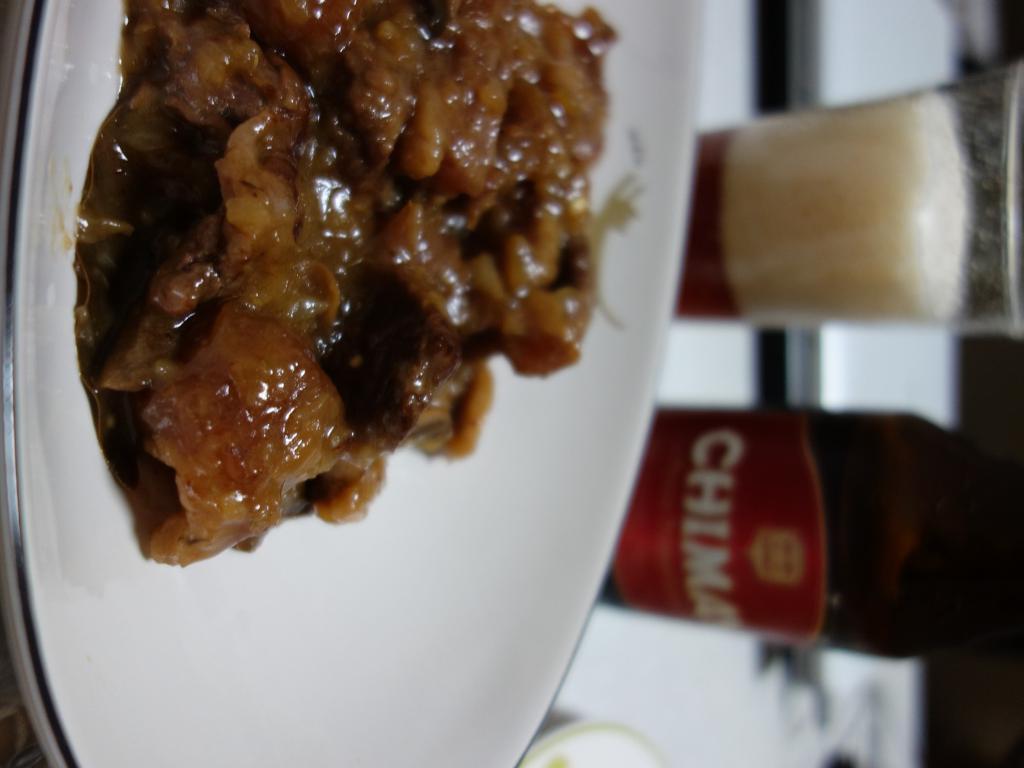In one or two sentences, can you explain what this image depicts? In this image I can see the food which is in brown color and the food is in the plate. The plate is in white color, background I can see a bottle and a glass. 